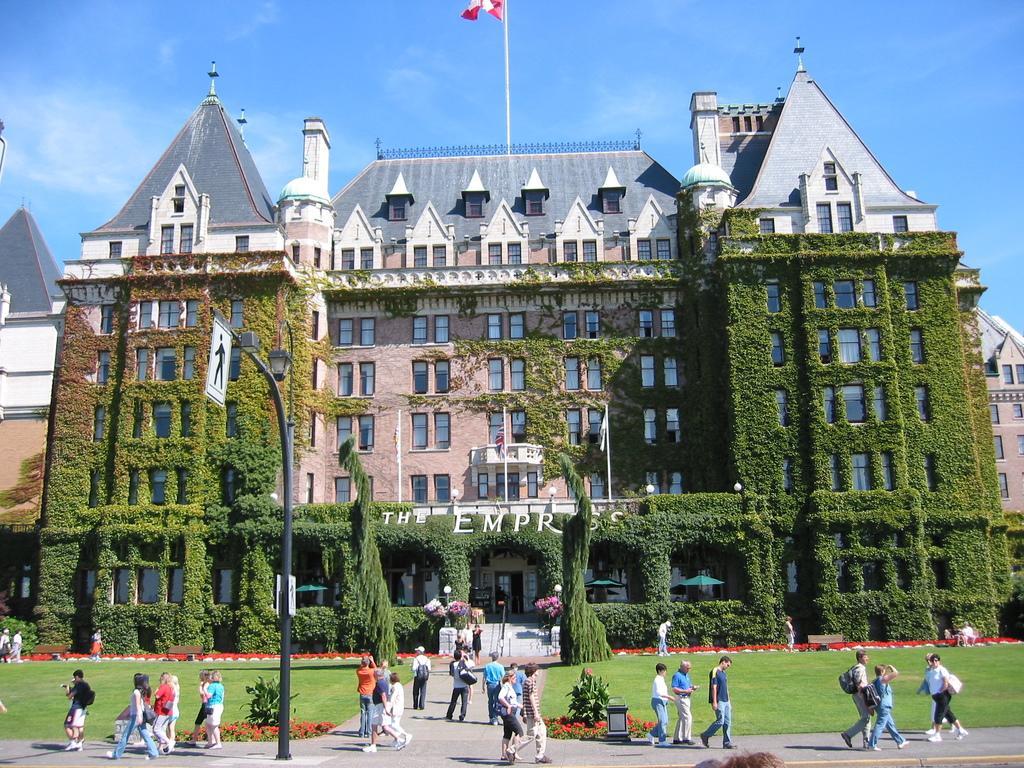Could you give a brief overview of what you see in this image? In this image a group of people are walking. There is a building in the image. There are many trees and plants in the image. 